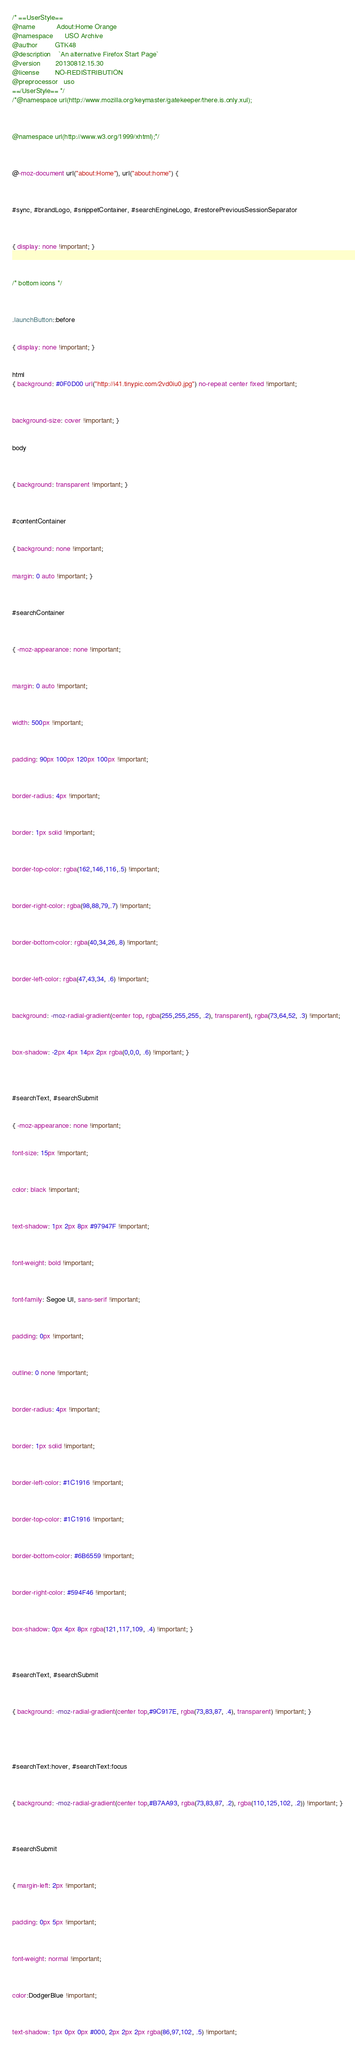<code> <loc_0><loc_0><loc_500><loc_500><_CSS_>/* ==UserStyle==
@name           Adout:Home Orange
@namespace      USO Archive
@author         GTK48
@description    `An alternative Firefox Start Page`
@version        20130812.15.30
@license        NO-REDISTRIBUTION
@preprocessor   uso
==/UserStyle== */
/*@namespace url(http://www.mozilla.org/keymaster/gatekeeper/there.is.only.xul);



@namespace url(http://www.w3.org/1999/xhtml);*/



@-moz-document url("about:Home"), url("about:home") {



#sync, #brandLogo, #snippetContainer, #searchEngineLogo, #restorePreviousSessionSeparator



{ display: none !important; }



/* bottom icons */



.launchButton::before


{ display: none !important; }


html
{ background: #0F0D00 url("http://i41.tinypic.com/2vd0iu0.jpg") no-repeat center fixed !important; 



background-size: cover !important; }


body



{ background: transparent !important; }



#contentContainer


{ background: none !important;


margin: 0 auto !important; }



#searchContainer



{ -moz-appearance: none !important; 



margin: 0 auto !important;



width: 500px !important;



padding: 90px 100px 120px 100px !important;



border-radius: 4px !important;



border: 1px solid !important;



border-top-color: rgba(162,146,116,.5) !important;



border-right-color: rgba(98,88,79,.7) !important;



border-bottom-color: rgba(40,34,26,.8) !important;



border-left-color: rgba(47,43,34, .6) !important;



background: -moz-radial-gradient(center top, rgba(255,255,255, .2), transparent), rgba(73,64,52, .3) !important;



box-shadow: -2px 4px 14px 2px rgba(0,0,0, .6) !important; }




#searchText, #searchSubmit


{ -moz-appearance: none !important; 


font-size: 15px !important;



color: black !important;



text-shadow: 1px 2px 8px #97947F !important;



font-weight: bold !important;



font-family: Segoe UI, sans-serif !important;



padding: 0px !important;



outline: 0 none !important;



border-radius: 4px !important;



border: 1px solid !important;



border-left-color: #1C1916 !important;



border-top-color: #1C1916 !important; 



border-bottom-color: #6B6559 !important;



border-right-color: #594F46 !important;



box-shadow: 0px 4px 8px rgba(121,117,109, .4) !important; }




#searchText, #searchSubmit



{ background: -moz-radial-gradient(center top,#9C917E, rgba(73,83,87, .4), transparent) !important; }





#searchText:hover, #searchText:focus



{ background: -moz-radial-gradient(center top,#B7AA93, rgba(73,83,87, .2), rgba(110,125,102, .2)) !important; }




#searchSubmit



{ margin-left: 2px !important;



padding: 0px 5px !important;



font-weight: normal !important;



color:DodgerBlue !important;



text-shadow: 1px 0px 0px #000, 2px 2px 2px rgba(86,97,102, .5) !important;


</code> 